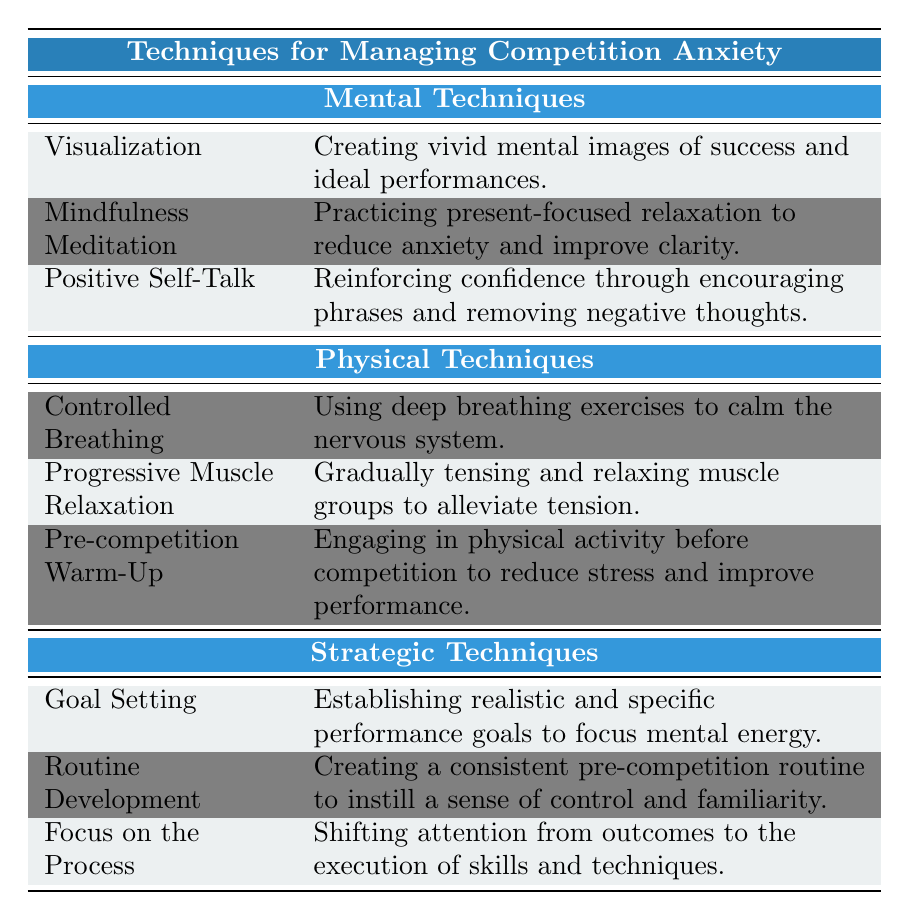What mental technique focuses on creating vivid images of success? The table lists "Visualization" under mental techniques, which specifically involves creating vivid mental images of success and ideal performances.
Answer: Visualization How many physical techniques are listed in the table? The table identifies three physical techniques: Controlled Breathing, Progressive Muscle Relaxation, and Pre-competition Warm-Up, totaling three.
Answer: 3 Is "Mindfulness Meditation" considered a mental technique? Yes, the table categorizes "Mindfulness Meditation" under mental techniques, indicating it is indeed one of them.
Answer: Yes Which strategic technique aims to shift the focus from outcomes to skills execution? The table shows "Focus on the Process" as the strategic technique that emphasizes shifting attention from the results to the execution of skills and techniques.
Answer: Focus on the Process What is the primary purpose of "Controlled Breathing" according to the table? The description for "Controlled Breathing" states it's used to calm the nervous system through deep breathing exercises, indicating its purpose is to reduce anxiety.
Answer: To calm the nervous system If a person practices all three mental techniques, what is the total number of techniques they are utilizing? The table outlines three mental techniques (Visualization, Mindfulness Meditation, Positive Self-Talk), so practicing all would equal three techniques total.
Answer: 3 Which type of technique includes "Routine Development"? The table lists "Routine Development" as a strategic technique, meaning it falls under the category of strategic techniques.
Answer: Strategic Techniques Are there more mental techniques than physical techniques in the table? Yes, the table shows three mental techniques and three physical techniques, indicating they are equal in number, but not more mental techniques than physical techniques.
Answer: No How many total techniques are listed across all categories in the table? The total is determined by adding the number of techniques from each category: 3 mental + 3 physical + 3 strategic = 9 techniques total.
Answer: 9 Which physical technique is designed to alleviate tension? The table describes "Progressive Muscle Relaxation" as a physical technique that involves gradually tensing and relaxing muscle groups to alleviate tension.
Answer: Progressive Muscle Relaxation 